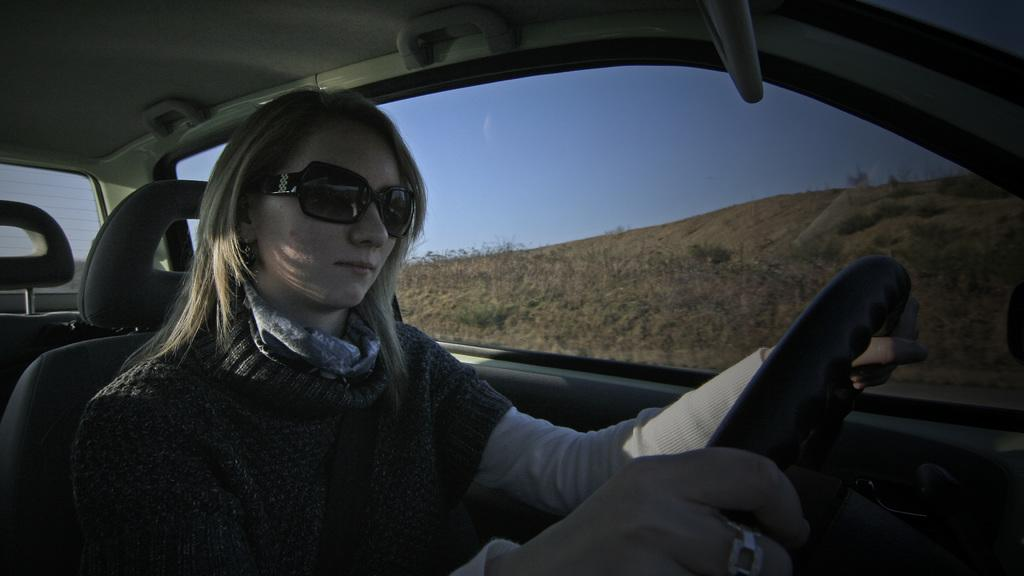Who is the main subject in the image? There is a woman in the image. What is the woman doing in the image? The woman is driving a vehicle. What accessory is the woman wearing in the image? The woman is wearing black shades. What can be seen in the background of the image? There is a clear view of the sky in the background of the image. How many porters are assisting the woman in the image? There are no porters present in the image; the woman is driving a vehicle on her own. What type of waves can be seen in the image? There are no waves visible in the image; it features a woman driving a vehicle with a clear view of the sky in the background. 